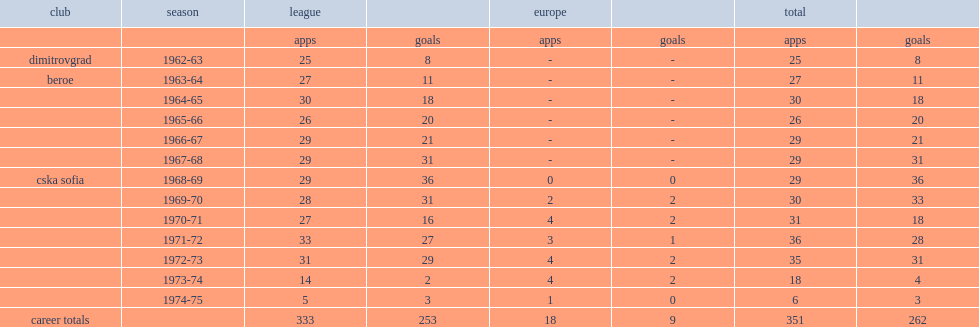How many goals did petar zhekov score in league totally? 253.0. 